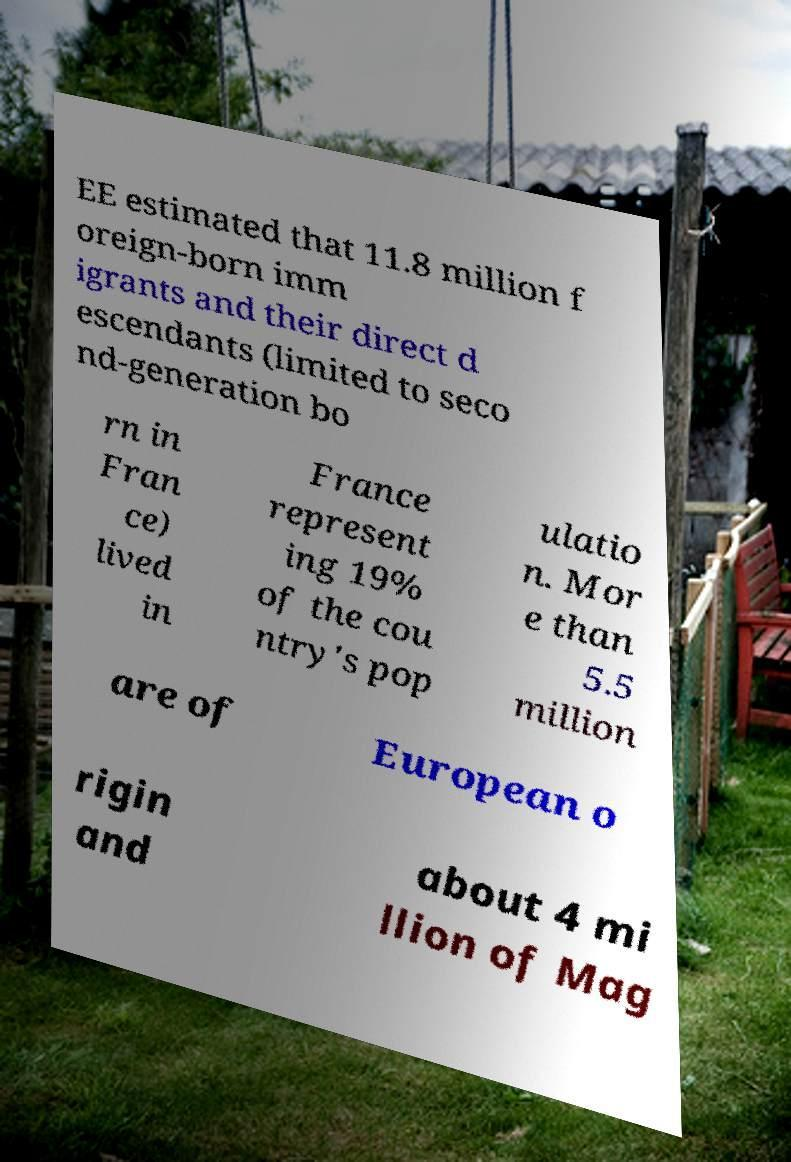What messages or text are displayed in this image? I need them in a readable, typed format. EE estimated that 11.8 million f oreign-born imm igrants and their direct d escendants (limited to seco nd-generation bo rn in Fran ce) lived in France represent ing 19% of the cou ntry's pop ulatio n. Mor e than 5.5 million are of European o rigin and about 4 mi llion of Mag 